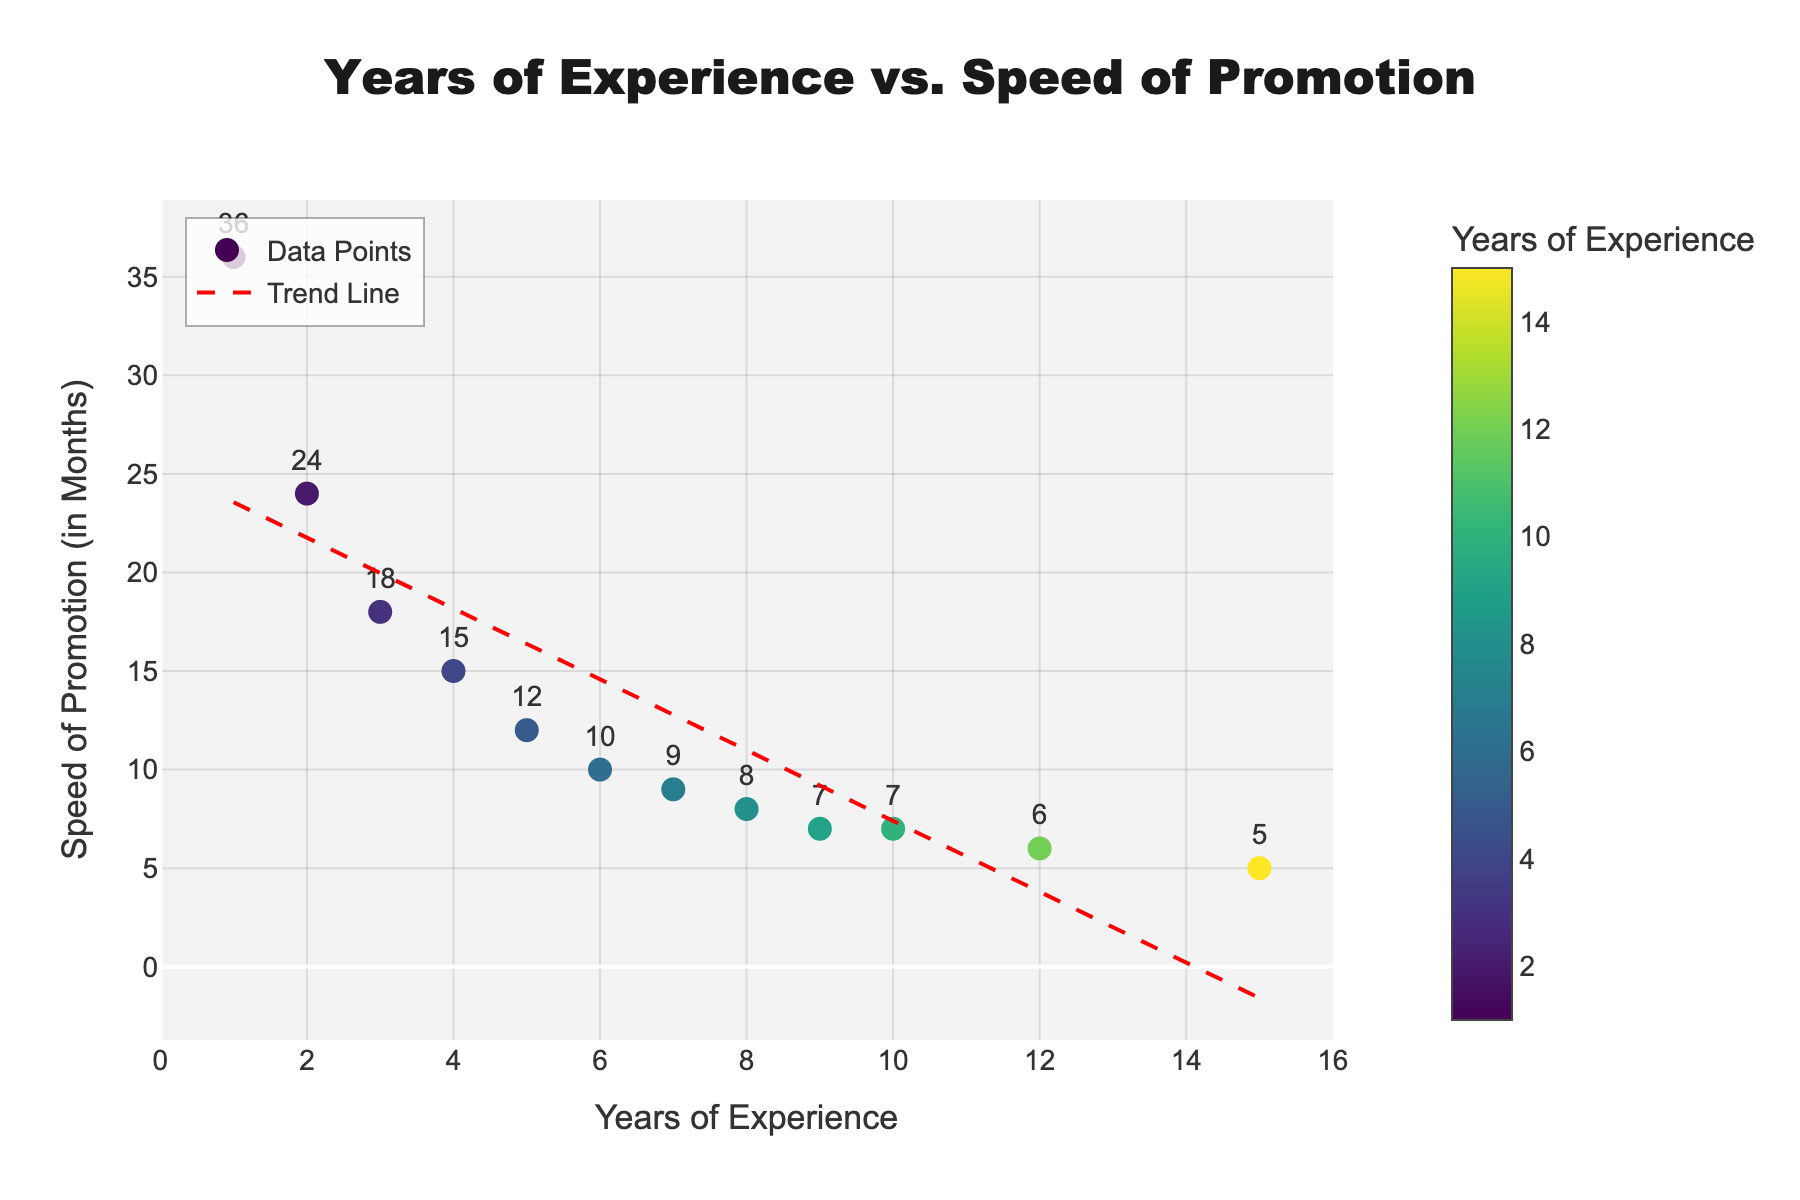How many data points are shown in the scatter plot? Count the number of marker points visible in the plot, which corresponds to the entries in the provided data.
Answer: 12 What are the axis titles of the scatter plot? Look at the titles displayed along the X-axis and the Y-axis of the scatter plot. The X-axis represents "Years of Experience" and the Y-axis represents "Speed of Promotion (in Months)".
Answer: Years of Experience and Speed of Promotion (in Months) Which data point has the fastest speed of promotion? Find the data point with the smallest Y-value since the speed of promotion is measured in months and a smaller number indicates a faster promotion. The point with 15 years of experience has the fastest promotion speed of 5 months.
Answer: 15 years, 5 months Is there an observable trend in the data points on the scatter plot? Observe the red dashed trend line that indicates a linear relationship between the years of experience and speed of promotion. The line slopes downwards, indicating an inverse relationship; as years of experience increase, the speed of promotion in months decreases.
Answer: Yes, as experience increases, promotion speed increases What is the trend line equation? The trend line is represented by a straight line, and its equation can be determined by the slope and intercept provided. This information is shown visually in the plot, generally at the top or via legend details. Given that exact coefficients aren't explicitly shown here, you would infer it from the red dashed line if displayed.
Answer: Not specified (implied linear downward trend) What speeds of promotion correspond to 1 year and 15 years of experience? Locate the Y-values for the data points where the X-values are 1 and 15. For 1 year of experience, the speed of promotion is 36 months, and for 15 years, it is 5 months.
Answer: 36 months and 5 months How does the speed of promotion change from 4 years of experience to 8 years of experience? Find the Y-values for 4 years and 8 years. The speed of promotion changes from 15 months at 4 years to 8 months at 8 years. The difference in speed is 15 - 8 = 7 months faster.
Answer: 7 months faster What is the color range used in the scatter plot for the data points? Observe the color bar present on the right-hand side of the scatter plot. It typically shows a gradient scale from a starting color to an ending color representing the range of "Years of Experience", here using the Viridis color scheme.
Answer: From lighter to darker colors as experience increases What’s the average speed of promotion for the first five data points (1-5 years of experience)? Add the speeds for the first five data points: 36, 24, 18, 15, and 12 months, then divide the sum by 5. (36 + 24 + 18 + 15 + 12 = 105, so the average is 105 / 5 = 21 months).
Answer: 21 months Based on the trend line, which helps decrease the speed of promotion faster: initial years of experience or high years of experience? Observe the slope of the trend line. Given that the slope is negative and appears steeper at lower experience levels, initial years tend to have a faster reduction in promotion time before the rates stabilize. Initial years show a more drastic decrease.
Answer: Initial years How does the speed of promotion between 8 and 12 years of experience compare? Find the Y-values for 8 and 12 years. At 8 years, the speed is 8 months, and at 12 years, it is 6 months, so the difference is 8 - 6 = 2 months.
Answer: 2 months slower at 8 years compared to 12 years 